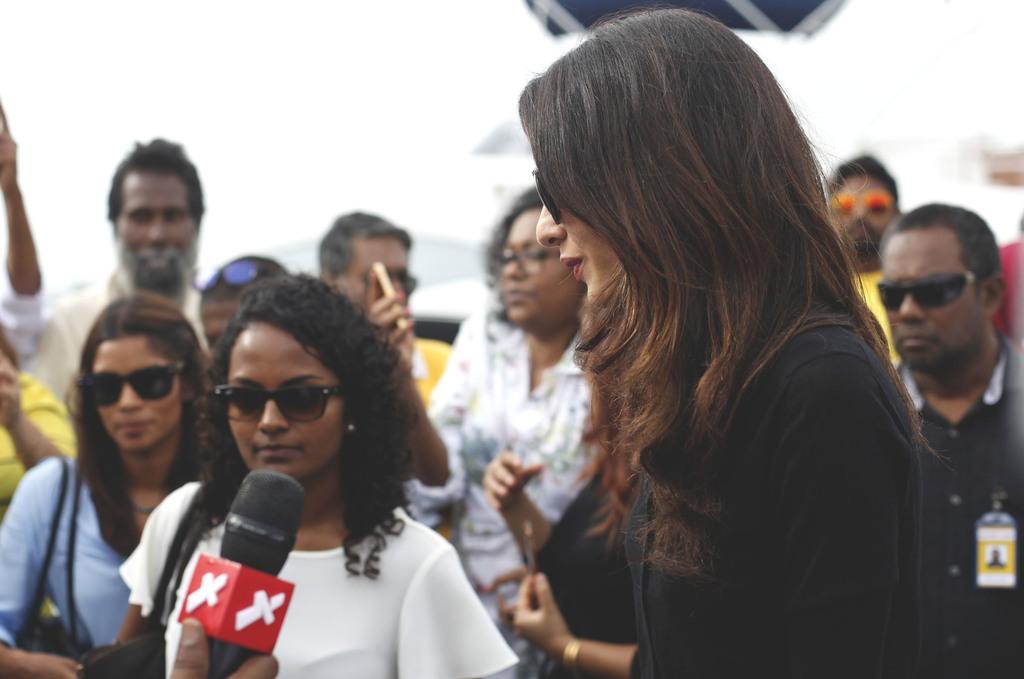Please provide a concise description of this image. In front of the image there is a lady with goggles. And she is standing. Behind her there are many people standing. And there are few people with goggles. On the left bottom of the image there is a mic. 